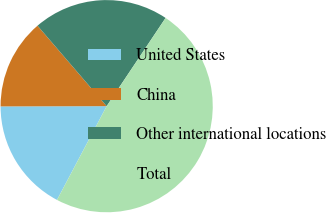<chart> <loc_0><loc_0><loc_500><loc_500><pie_chart><fcel>United States<fcel>China<fcel>Other international locations<fcel>Total<nl><fcel>17.21%<fcel>13.74%<fcel>20.67%<fcel>48.38%<nl></chart> 